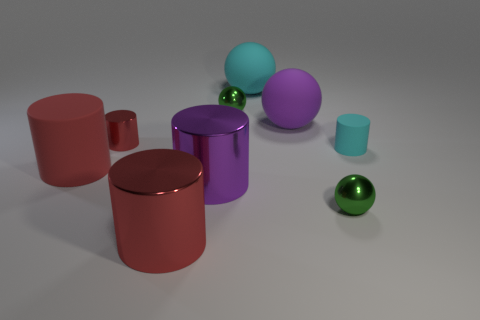Do the tiny cyan object and the large purple cylinder have the same material?
Give a very brief answer. No. What number of other objects are the same color as the tiny shiny cylinder?
Provide a short and direct response. 2. Is there a shiny thing of the same size as the cyan rubber ball?
Ensure brevity in your answer.  Yes. There is a red object that is the same size as the cyan cylinder; what material is it?
Make the answer very short. Metal. Does the red matte thing have the same size as the green sphere behind the purple sphere?
Your answer should be compact. No. What number of rubber objects are either tiny red cubes or large cyan objects?
Offer a very short reply. 1. How many large matte objects have the same shape as the tiny cyan matte thing?
Provide a short and direct response. 1. What is the material of the other big cylinder that is the same color as the big rubber cylinder?
Your answer should be compact. Metal. There is a metal cylinder behind the big purple metallic cylinder; does it have the same size as the cyan object that is in front of the small red cylinder?
Provide a short and direct response. Yes. There is a small metallic thing behind the big purple ball; what shape is it?
Offer a very short reply. Sphere. 